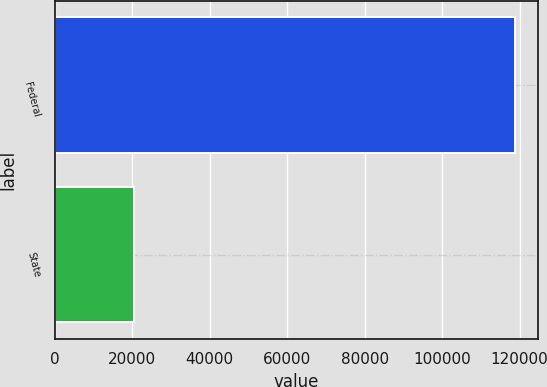Convert chart. <chart><loc_0><loc_0><loc_500><loc_500><bar_chart><fcel>Federal<fcel>State<nl><fcel>118764<fcel>20595<nl></chart> 